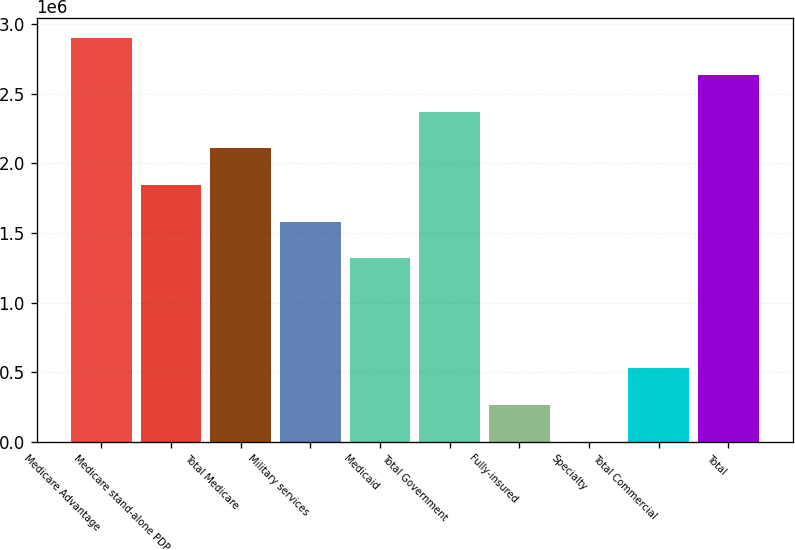Convert chart to OTSL. <chart><loc_0><loc_0><loc_500><loc_500><bar_chart><fcel>Medicare Advantage<fcel>Medicare stand-alone PDP<fcel>Total Medicare<fcel>Military services<fcel>Medicaid<fcel>Total Government<fcel>Fully-insured<fcel>Specialty<fcel>Total Commercial<fcel>Total<nl><fcel>2.89876e+06<fcel>1.84492e+06<fcel>2.10838e+06<fcel>1.58146e+06<fcel>1.318e+06<fcel>2.37184e+06<fcel>264163<fcel>703<fcel>527623<fcel>2.6353e+06<nl></chart> 